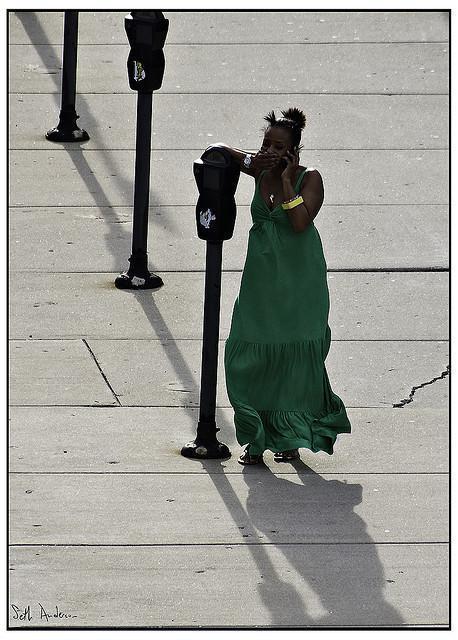How many parking meters are in the picture?
Give a very brief answer. 2. 